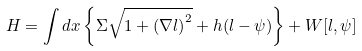<formula> <loc_0><loc_0><loc_500><loc_500>H = \int d { x } \left \{ \Sigma \sqrt { 1 + \left ( \nabla l \right ) ^ { 2 } } + h ( l - \psi ) \right \} + W [ l , \psi ]</formula> 